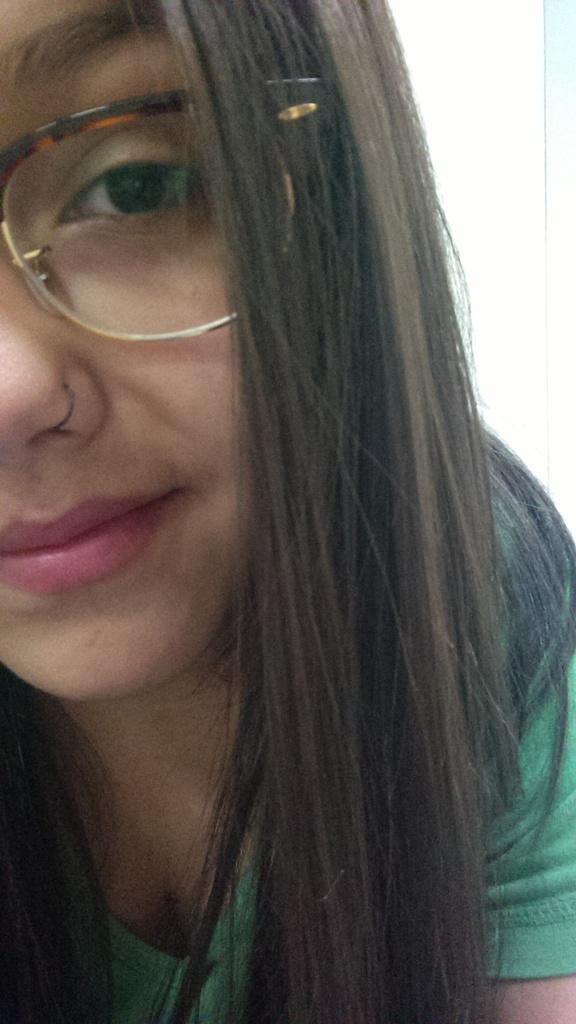What is present in the image? There is a person in the image. Can you describe the person's appearance? The person is wearing spectacles. What is the level of pollution in the image? There is no information about pollution in the image, as it only features a person wearing spectacles. 